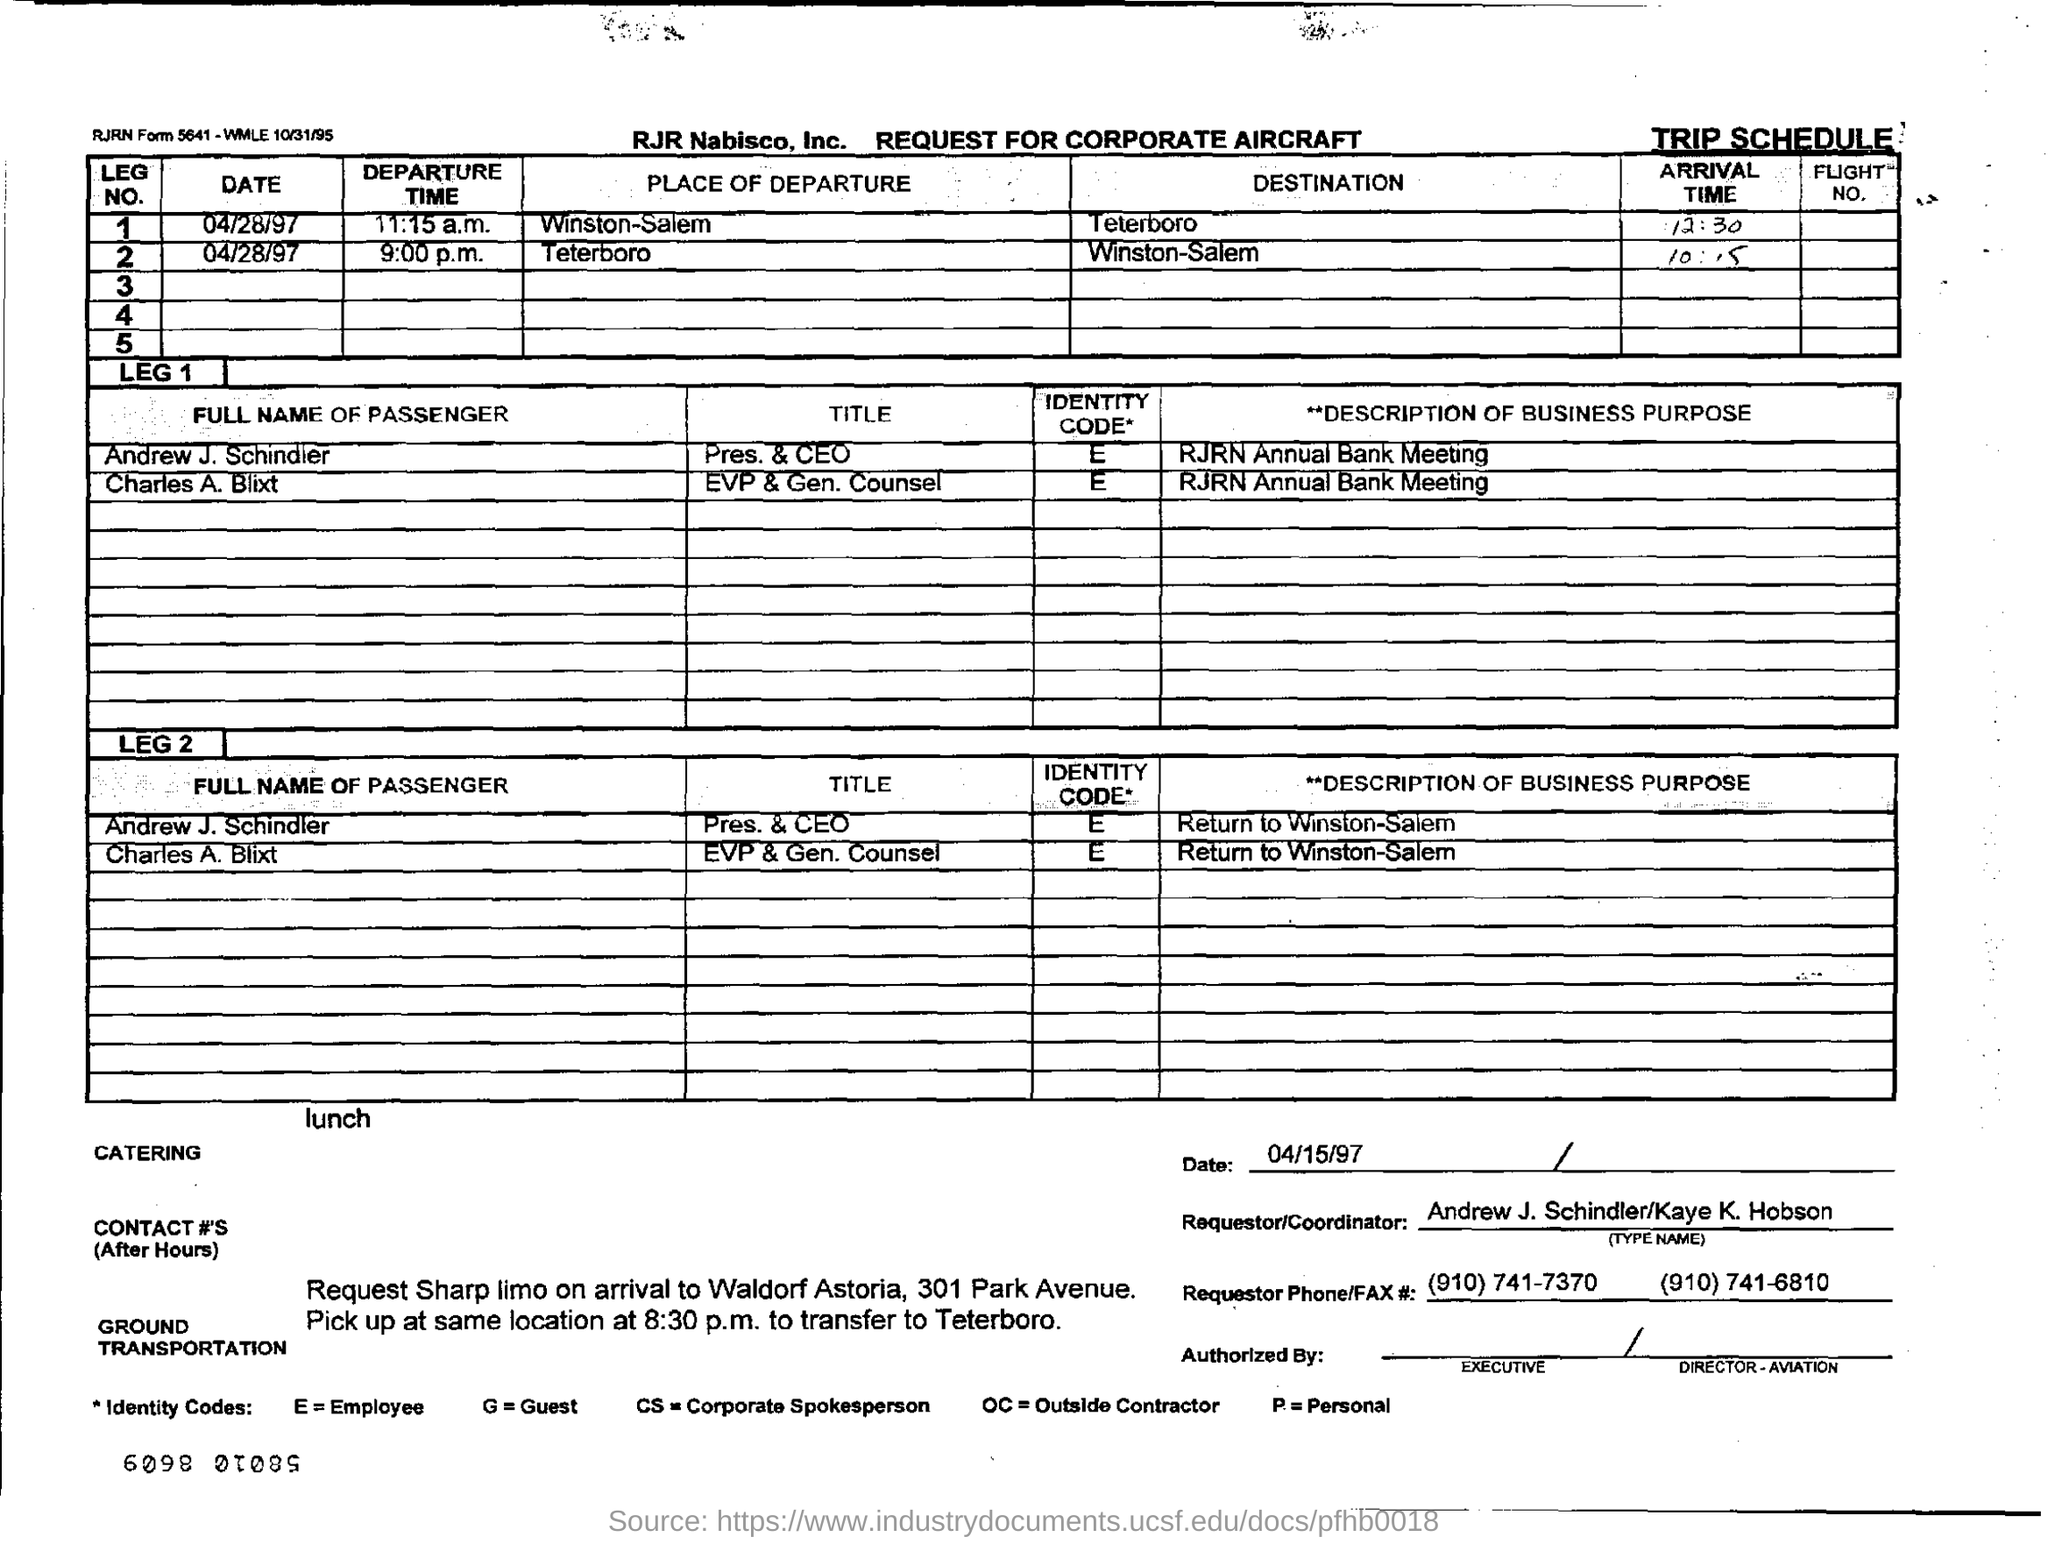What is the document title?
Offer a very short reply. REQUEST FOR CORPORATE AIRCRAFT. What is the title of Andrew J. Schindler?
Ensure brevity in your answer.  Pres & ceo. Who is Charles A. Blixt?
Give a very brief answer. Evp & gen . counsel. Who is the Requestor/Coordinator?
Your answer should be very brief. Andrew J. Schindler/Kaye K. Hobson. 